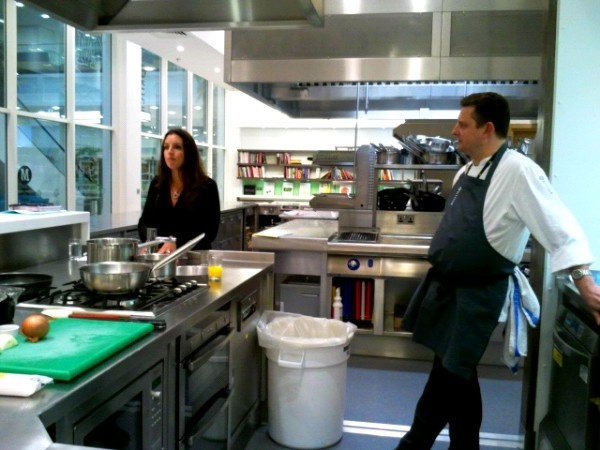Describe the objects in this image and their specific colors. I can see people in teal, black, white, darkgray, and lightblue tones, oven in teal, black, and gray tones, people in teal, black, maroon, and brown tones, oven in teal, black, gray, purple, and darkgray tones, and bowl in teal, black, and gray tones in this image. 